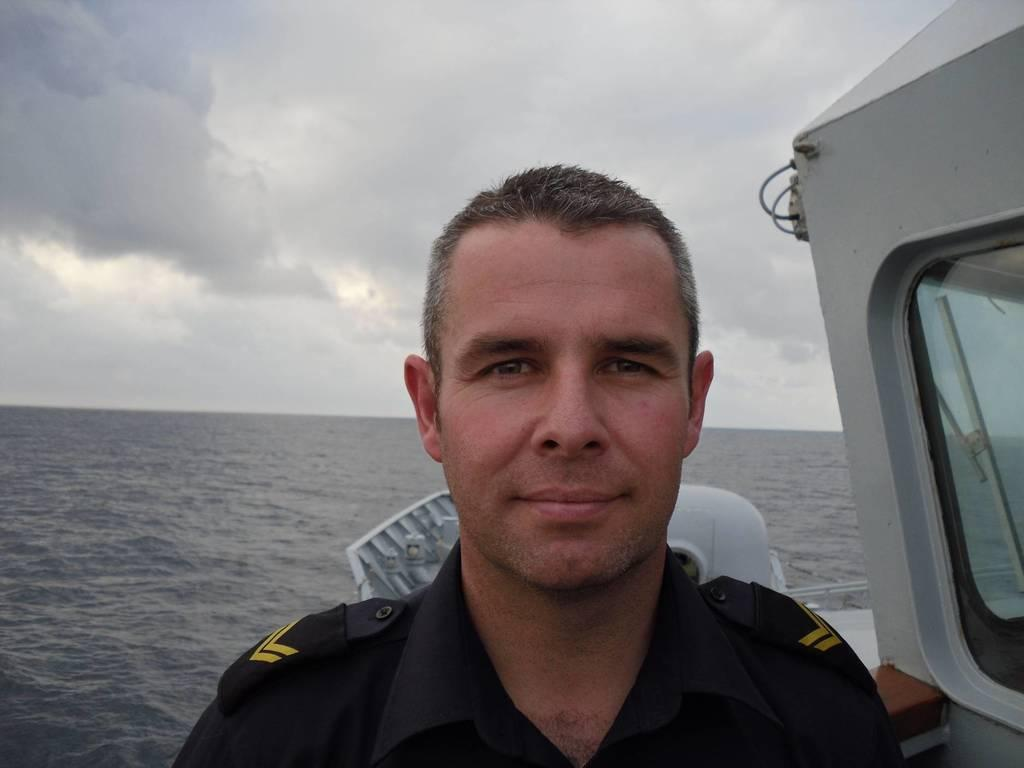What is the person in the image standing on? The person is standing on a ship in the image. What can be seen behind the person? There is water visible behind the person. What is visible in the sky at the top of the image? There are clouds in the sky at the top of the image. What type of relation is the person on the ship discussing with the committee in the image? There is no committee present in the image, and the person's actions or conversations cannot be determined from the image alone. 